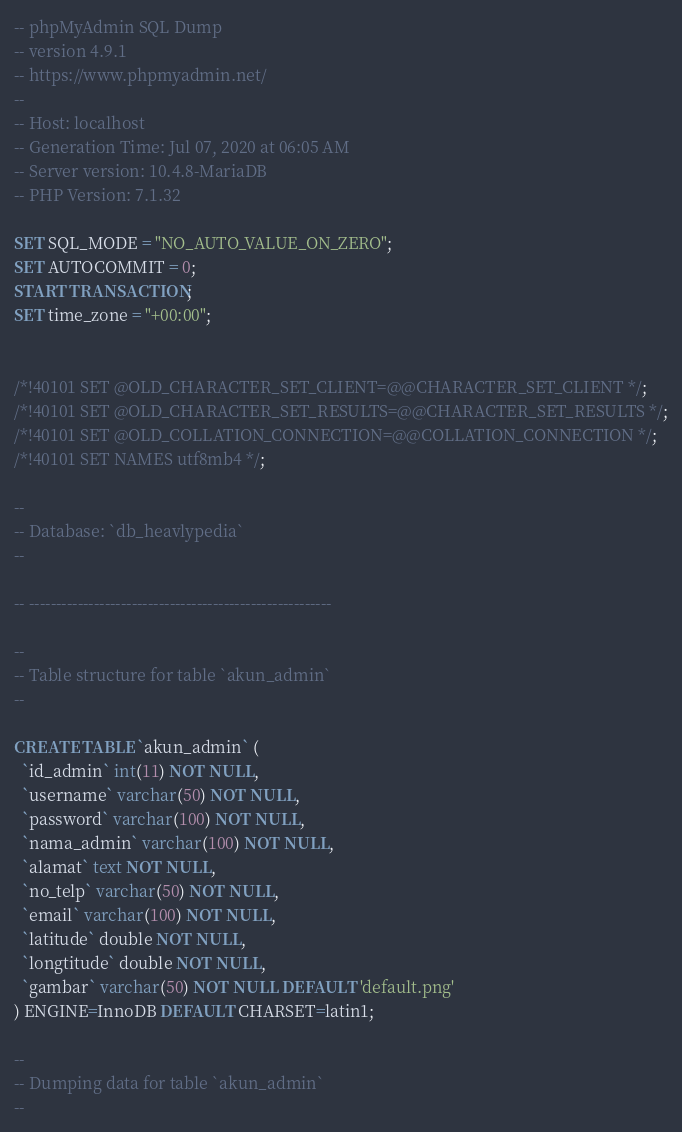Convert code to text. <code><loc_0><loc_0><loc_500><loc_500><_SQL_>-- phpMyAdmin SQL Dump
-- version 4.9.1
-- https://www.phpmyadmin.net/
--
-- Host: localhost
-- Generation Time: Jul 07, 2020 at 06:05 AM
-- Server version: 10.4.8-MariaDB
-- PHP Version: 7.1.32

SET SQL_MODE = "NO_AUTO_VALUE_ON_ZERO";
SET AUTOCOMMIT = 0;
START TRANSACTION;
SET time_zone = "+00:00";


/*!40101 SET @OLD_CHARACTER_SET_CLIENT=@@CHARACTER_SET_CLIENT */;
/*!40101 SET @OLD_CHARACTER_SET_RESULTS=@@CHARACTER_SET_RESULTS */;
/*!40101 SET @OLD_COLLATION_CONNECTION=@@COLLATION_CONNECTION */;
/*!40101 SET NAMES utf8mb4 */;

--
-- Database: `db_heavlypedia`
--

-- --------------------------------------------------------

--
-- Table structure for table `akun_admin`
--

CREATE TABLE `akun_admin` (
  `id_admin` int(11) NOT NULL,
  `username` varchar(50) NOT NULL,
  `password` varchar(100) NOT NULL,
  `nama_admin` varchar(100) NOT NULL,
  `alamat` text NOT NULL,
  `no_telp` varchar(50) NOT NULL,
  `email` varchar(100) NOT NULL,
  `latitude` double NOT NULL,
  `longtitude` double NOT NULL,
  `gambar` varchar(50) NOT NULL DEFAULT 'default.png'
) ENGINE=InnoDB DEFAULT CHARSET=latin1;

--
-- Dumping data for table `akun_admin`
--
</code> 